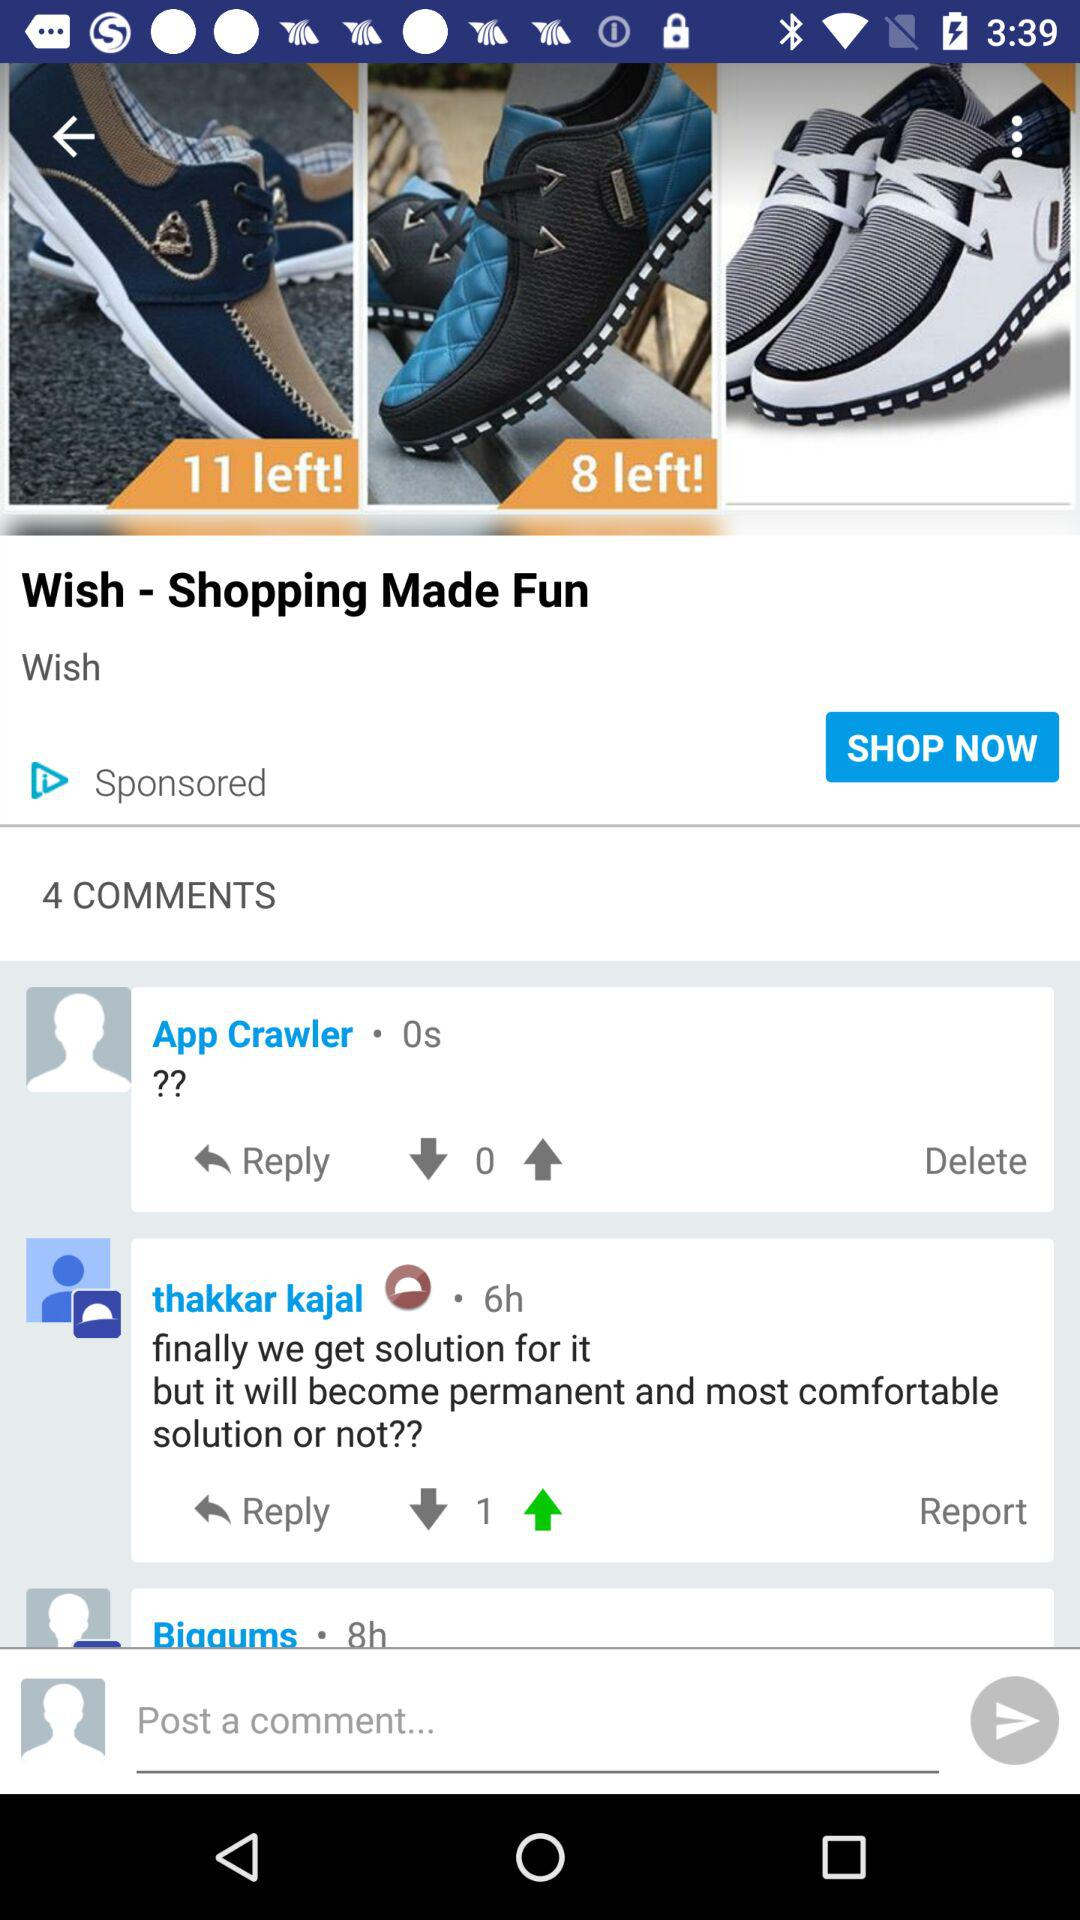How many comments are there on this page?
Answer the question using a single word or phrase. 4 